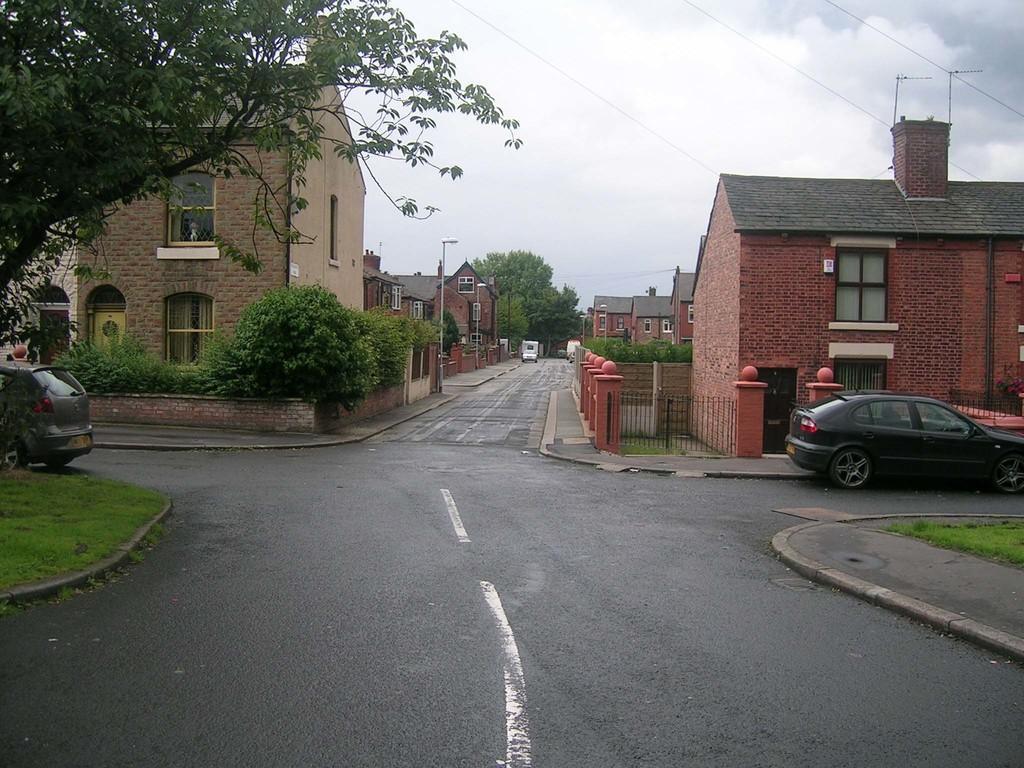Could you give a brief overview of what you see in this image? As we can see in the image there is grass, plants, cars, buildings, street lamps and windows. At the top there is sky and clouds. 